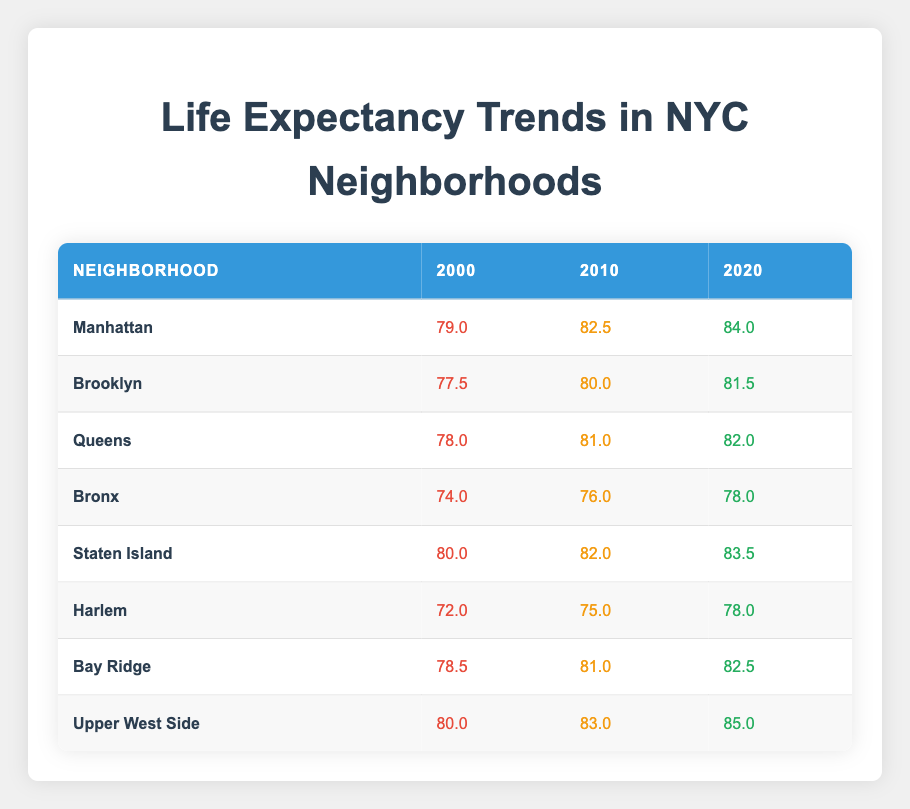What was the life expectancy in Manhattan in 2010? According to the table, the life expectancy for Manhattan in 2010 is directly given as 82.5.
Answer: 82.5 Which neighborhood had the lowest life expectancy in 2000? The table shows that Bronx had the lowest life expectancy in 2000, recorded at 74.0.
Answer: Bronx What was the average life expectancy in Brooklyn for the years 2010 and 2020? To find the average for Brooklyn in 2010 and 2020, sum those values (80.0 + 81.5 = 161.5) and then divide by 2 to get the average (161.5 / 2 = 80.75).
Answer: 80.75 Is the life expectancy in Staten Island higher than in Harlem for the year 2020? According to the table, Staten Island's life expectancy in 2020 is 83.5, while Harlem's is 78.0. Since 83.5 is greater than 78.0, the statement is true.
Answer: Yes What was the increase in life expectancy for Upper West Side from 2000 to 2020? The life expectancy for Upper West Side in 2000 was 80.0, and in 2020 it was 85.0. The increase is calculated by subtracting the earlier value from the later value (85.0 - 80.0 = 5.0).
Answer: 5.0 Which neighborhoods had a life expectancy of over 80 in 2020? The table reveals that in 2020, the neighborhoods with life expectancies over 80 are Manhattan (84.0), Staten Island (83.5), Upper West Side (85.0), and Queens (82.0).
Answer: Manhattan, Staten Island, Upper West Side, Queens Did the life expectancy in the Bronx increase or decrease from 2000 to 2010? From the table, it shows that life expectancy in the Bronx was 74.0 in 2000 and increased to 76.0 in 2010, hence there was an increase.
Answer: Increase What is the difference between the life expectancy of Brooklyn in 2020 and that of Staten Island in 2020? The life expectancy of Brooklyn in 2020 is 81.5 and that of Staten Island is 83.5. To find the difference, subtract Brooklyn's value from Staten Island's (83.5 - 81.5 = 2.0).
Answer: 2.0 